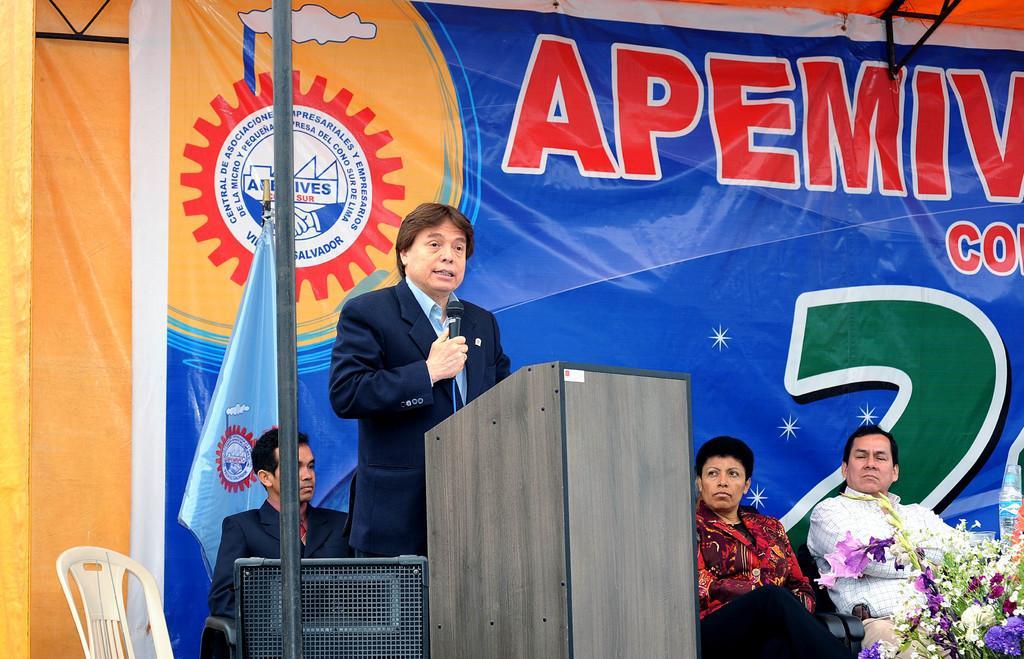In one or two sentences, can you explain what this image depicts? In this image we can see few people are sitting on the chair. There is loudspeaker, a podium,a banner and a bouquet in the image. A man is holding a microphone and speaking into it. 